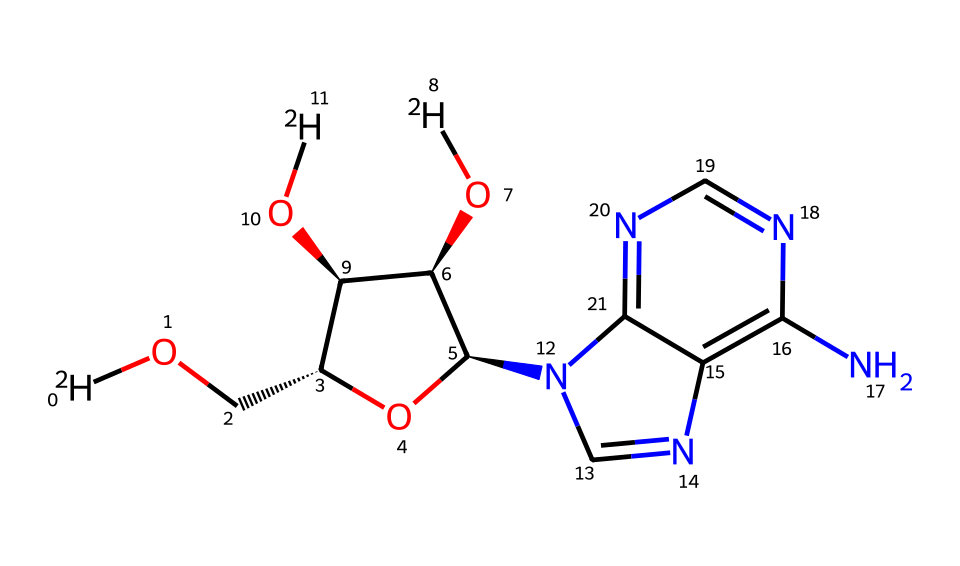What is the molecular formula of this compound? To determine the molecular formula, we count the number of each type of atom in the SMILES representation. The total counts lead to C, H, N, O, and D forming the respective counts needed for the formula.
Answer: C10H12N4O5D2 How many deuterium atoms are present in the structure? In the SMILES representation, deuterium is indicated by [2H]. Counting the instances of [2H] shows that there are three deuterium atoms.
Answer: 3 Which functional groups are present in this molecule? By analyzing the structure, we can identify hydroxyl groups (–OH), amine groups (–NH2), and a sugar ring structure. The recognition of these motifs gives us the necessary functional groups.
Answer: hydroxyl, amine, sugar How many nitrogen atoms are in the structure? By inspecting the SMILES closely, I count the nitrogen atoms represented by 'n' and 'N'. The total count indicates that there are four nitrogen atoms present in the structure.
Answer: 4 What type of nucleobase is this structure representing? The arrangement of nitrogen atoms within a fused ring structure indicates that the compound represents a purine or pyrimidine base. Since it contains both nitrogen and a sugar moiety, we determine it corresponds to adenine.
Answer: adenine What is the role of deuterium in the context of this molecular structure? Deuterium is a stable isotope of hydrogen that can be tracked in metabolic processes to trace molecular pathways. In DNA, it can provide insight into molecular dynamics and interactions during replication and transcription.
Answer: isotopic labeling 